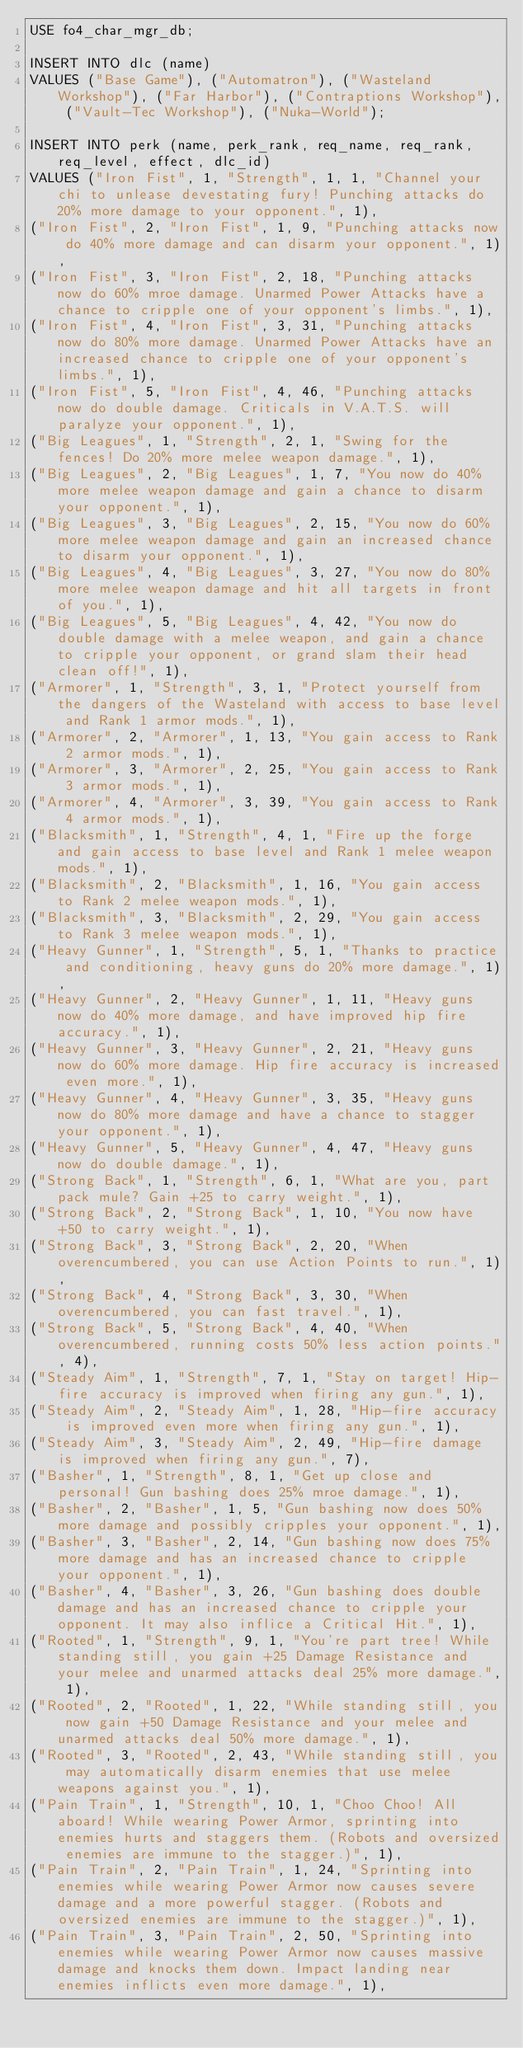Convert code to text. <code><loc_0><loc_0><loc_500><loc_500><_SQL_>USE fo4_char_mgr_db;

INSERT INTO dlc (name)
VALUES ("Base Game"), ("Automatron"), ("Wasteland Workshop"), ("Far Harbor"), ("Contraptions Workshop"), ("Vault-Tec Workshop"), ("Nuka-World");

INSERT INTO perk (name, perk_rank, req_name, req_rank, req_level, effect, dlc_id)
VALUES ("Iron Fist", 1, "Strength", 1, 1, "Channel your chi to unlease devestating fury! Punching attacks do 20% more damage to your opponent.", 1),
("Iron Fist", 2, "Iron Fist", 1, 9, "Punching attacks now do 40% more damage and can disarm your opponent.", 1),
("Iron Fist", 3, "Iron Fist", 2, 18, "Punching attacks now do 60% mroe damage. Unarmed Power Attacks have a chance to cripple one of your opponent's limbs.", 1),
("Iron Fist", 4, "Iron Fist", 3, 31, "Punching attacks now do 80% more damage. Unarmed Power Attacks have an increased chance to cripple one of your opponent's limbs.", 1),
("Iron Fist", 5, "Iron Fist", 4, 46, "Punching attacks now do double damage. Criticals in V.A.T.S. will paralyze your opponent.", 1),
("Big Leagues", 1, "Strength", 2, 1, "Swing for the fences! Do 20% more melee weapon damage.", 1),
("Big Leagues", 2, "Big Leagues", 1, 7, "You now do 40% more melee weapon damage and gain a chance to disarm your opponent.", 1),
("Big Leagues", 3, "Big Leagues", 2, 15, "You now do 60% more melee weapon damage and gain an increased chance to disarm your opponent.", 1),
("Big Leagues", 4, "Big Leagues", 3, 27, "You now do 80% more melee weapon damage and hit all targets in front of you.", 1),
("Big Leagues", 5, "Big Leagues", 4, 42, "You now do double damage with a melee weapon, and gain a chance to cripple your opponent, or grand slam their head clean off!", 1),
("Armorer", 1, "Strength", 3, 1, "Protect yourself from the dangers of the Wasteland with access to base level and Rank 1 armor mods.", 1),
("Armorer", 2, "Armorer", 1, 13, "You gain access to Rank 2 armor mods.", 1),
("Armorer", 3, "Armorer", 2, 25, "You gain access to Rank 3 armor mods.", 1),
("Armorer", 4, "Armorer", 3, 39, "You gain access to Rank 4 armor mods.", 1),
("Blacksmith", 1, "Strength", 4, 1, "Fire up the forge and gain access to base level and Rank 1 melee weapon mods.", 1),
("Blacksmith", 2, "Blacksmith", 1, 16, "You gain access to Rank 2 melee weapon mods.", 1),
("Blacksmith", 3, "Blacksmith", 2, 29, "You gain access to Rank 3 melee weapon mods.", 1),
("Heavy Gunner", 1, "Strength", 5, 1, "Thanks to practice and conditioning, heavy guns do 20% more damage.", 1),
("Heavy Gunner", 2, "Heavy Gunner", 1, 11, "Heavy guns now do 40% more damage, and have improved hip fire accuracy.", 1),
("Heavy Gunner", 3, "Heavy Gunner", 2, 21, "Heavy guns now do 60% more damage. Hip fire accuracy is increased even more.", 1),
("Heavy Gunner", 4, "Heavy Gunner", 3, 35, "Heavy guns now do 80% more damage and have a chance to stagger your opponent.", 1),
("Heavy Gunner", 5, "Heavy Gunner", 4, 47, "Heavy guns now do double damage.", 1),
("Strong Back", 1, "Strength", 6, 1, "What are you, part pack mule? Gain +25 to carry weight.", 1),
("Strong Back", 2, "Strong Back", 1, 10, "You now have +50 to carry weight.", 1),
("Strong Back", 3, "Strong Back", 2, 20, "When overencumbered, you can use Action Points to run.", 1),
("Strong Back", 4, "Strong Back", 3, 30, "When overencumbered, you can fast travel.", 1),
("Strong Back", 5, "Strong Back", 4, 40, "When overencumbered, running costs 50% less action points.", 4),
("Steady Aim", 1, "Strength", 7, 1, "Stay on target! Hip-fire accuracy is improved when firing any gun.", 1),
("Steady Aim", 2, "Steady Aim", 1, 28, "Hip-fire accuracy is improved even more when firing any gun.", 1),
("Steady Aim", 3, "Steady Aim", 2, 49, "Hip-fire damage is improved when firing any gun.", 7),
("Basher", 1, "Strength", 8, 1, "Get up close and personal! Gun bashing does 25% mroe damage.", 1),
("Basher", 2, "Basher", 1, 5, "Gun bashing now does 50% more damage and possibly cripples your opponent.", 1),
("Basher", 3, "Basher", 2, 14, "Gun bashing now does 75% more damage and has an increased chance to cripple your opponent.", 1),
("Basher", 4, "Basher", 3, 26, "Gun bashing does double damage and has an increased chance to cripple your opponent. It may also inflice a Critical Hit.", 1),
("Rooted", 1, "Strength", 9, 1, "You're part tree! While standing still, you gain +25 Damage Resistance and your melee and unarmed attacks deal 25% more damage.", 1),
("Rooted", 2, "Rooted", 1, 22, "While standing still, you now gain +50 Damage Resistance and your melee and unarmed attacks deal 50% more damage.", 1),
("Rooted", 3, "Rooted", 2, 43, "While standing still, you may automatically disarm enemies that use melee weapons against you.", 1),
("Pain Train", 1, "Strength", 10, 1, "Choo Choo! All aboard! While wearing Power Armor, sprinting into enemies hurts and staggers them. (Robots and oversized enemies are immune to the stagger.)", 1),
("Pain Train", 2, "Pain Train", 1, 24, "Sprinting into enemies while wearing Power Armor now causes severe damage and a more powerful stagger. (Robots and oversized enemies are immune to the stagger.)", 1),
("Pain Train", 3, "Pain Train", 2, 50, "Sprinting into enemies while wearing Power Armor now causes massive damage and knocks them down. Impact landing near enemies inflicts even more damage.", 1),</code> 